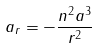Convert formula to latex. <formula><loc_0><loc_0><loc_500><loc_500>a _ { r } = - \frac { n ^ { 2 } a ^ { 3 } } { r ^ { 2 } }</formula> 